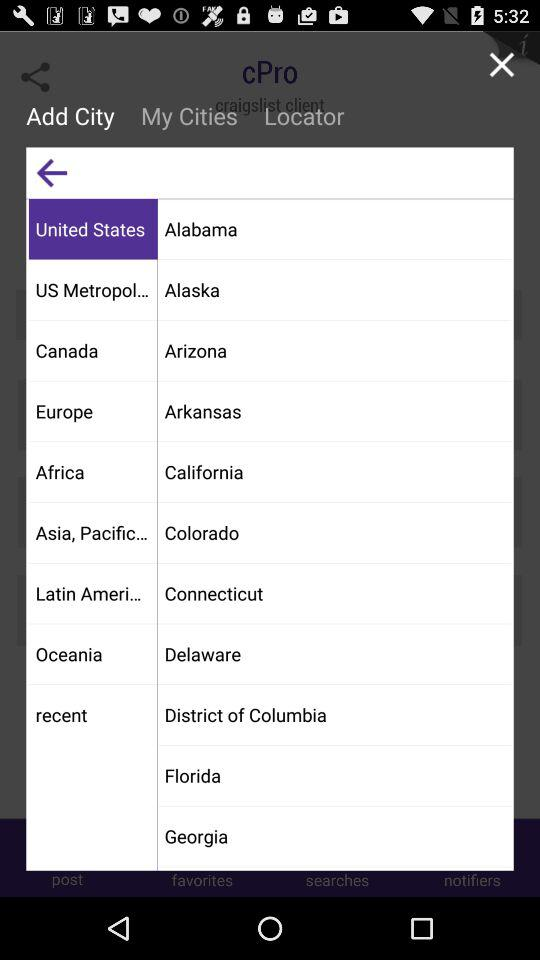What is the district of Columbia?
When the provided information is insufficient, respond with <no answer>. <no answer> 